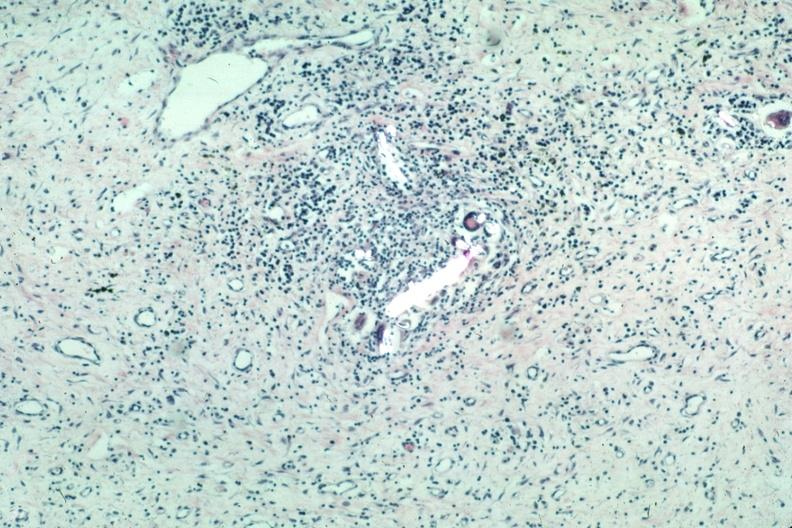what is present?
Answer the question using a single word or phrase. Suture granuloma 